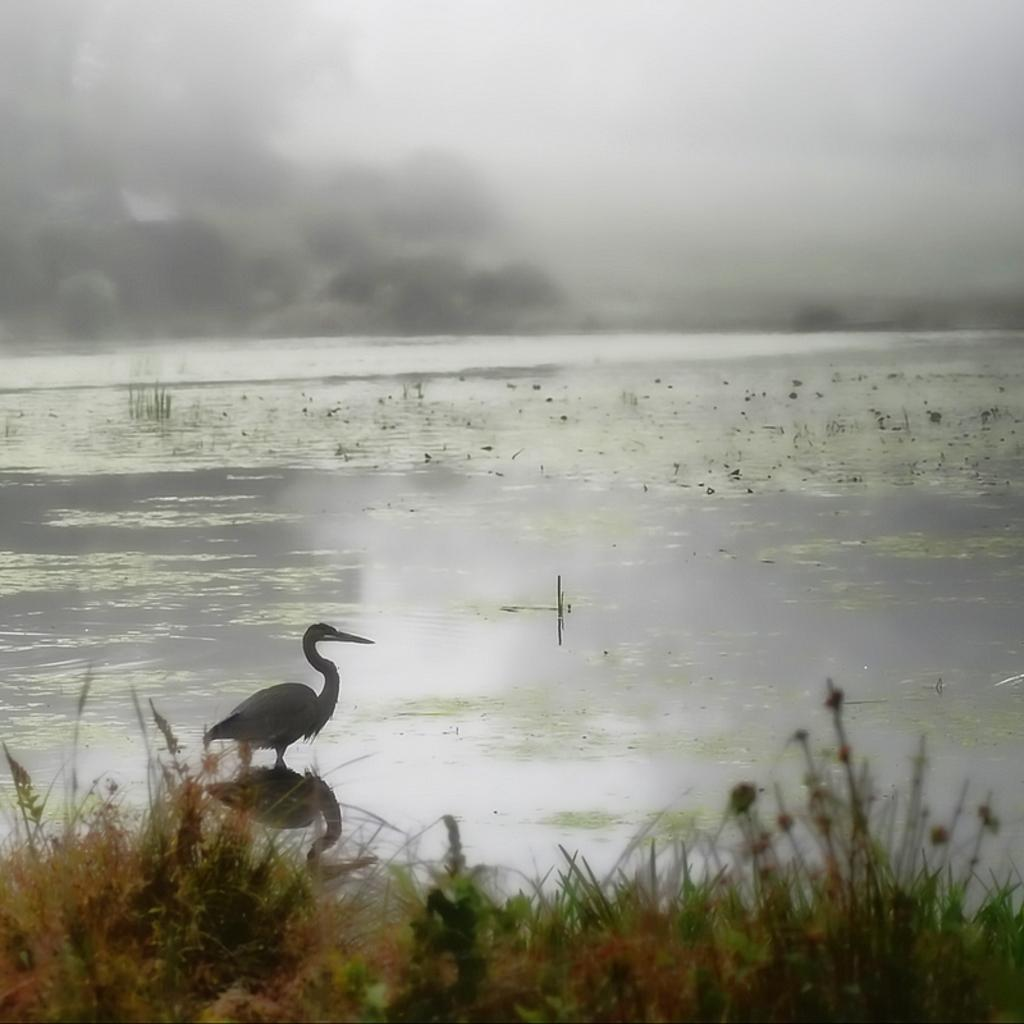What type of animal can be seen in the water in the image? There is a bird in the water in the image. What type of vegetation is visible in the image? There is grass visible in the image. What can be seen in the background of the image? There are clouds and the sky visible in the background. What is the taste of the brush in the image? There is no brush present in the image, so it is not possible to determine its taste. 